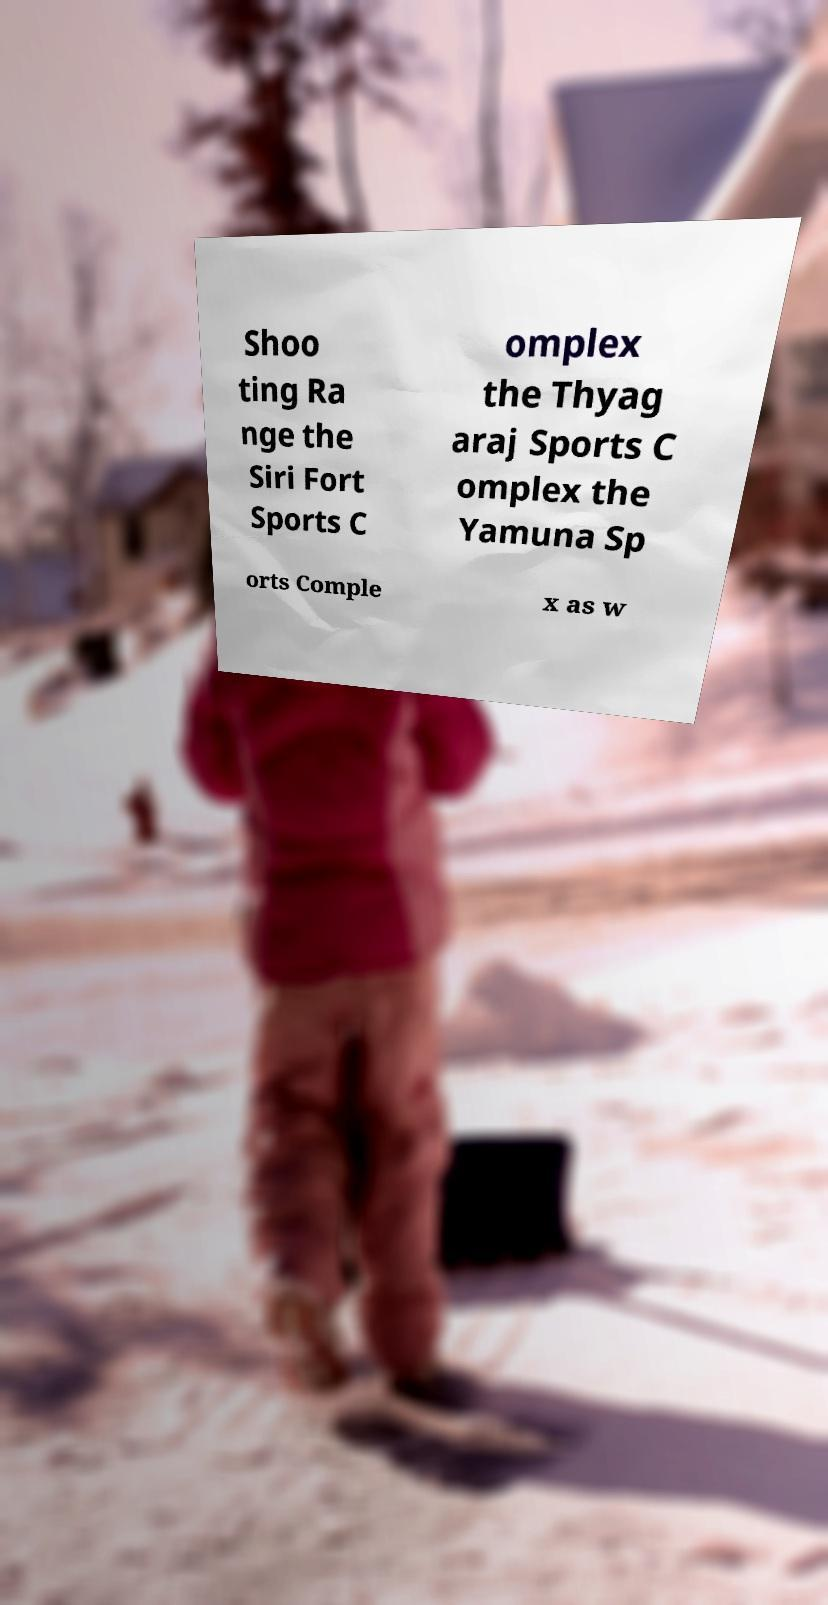Could you assist in decoding the text presented in this image and type it out clearly? Shoo ting Ra nge the Siri Fort Sports C omplex the Thyag araj Sports C omplex the Yamuna Sp orts Comple x as w 